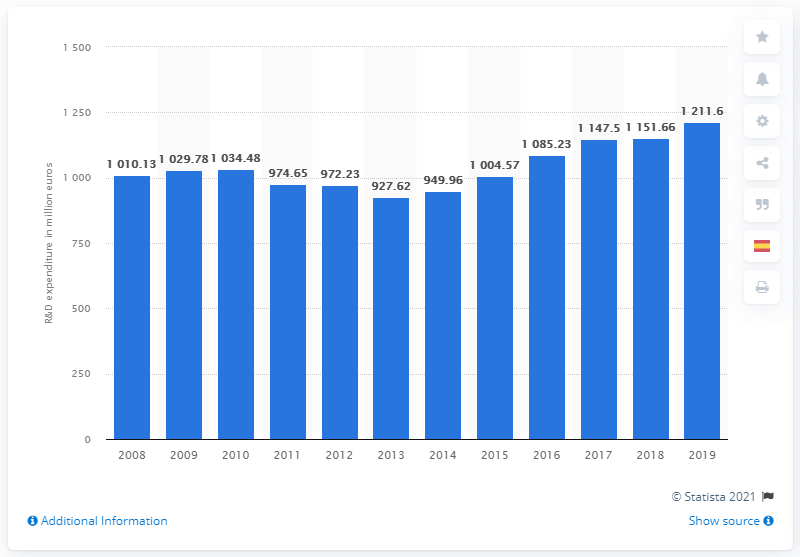Highlight a few significant elements in this photo. The Spanish pharmaceutical industry invested a total of 1,211.6 million euros in research and development projects in 2019. 